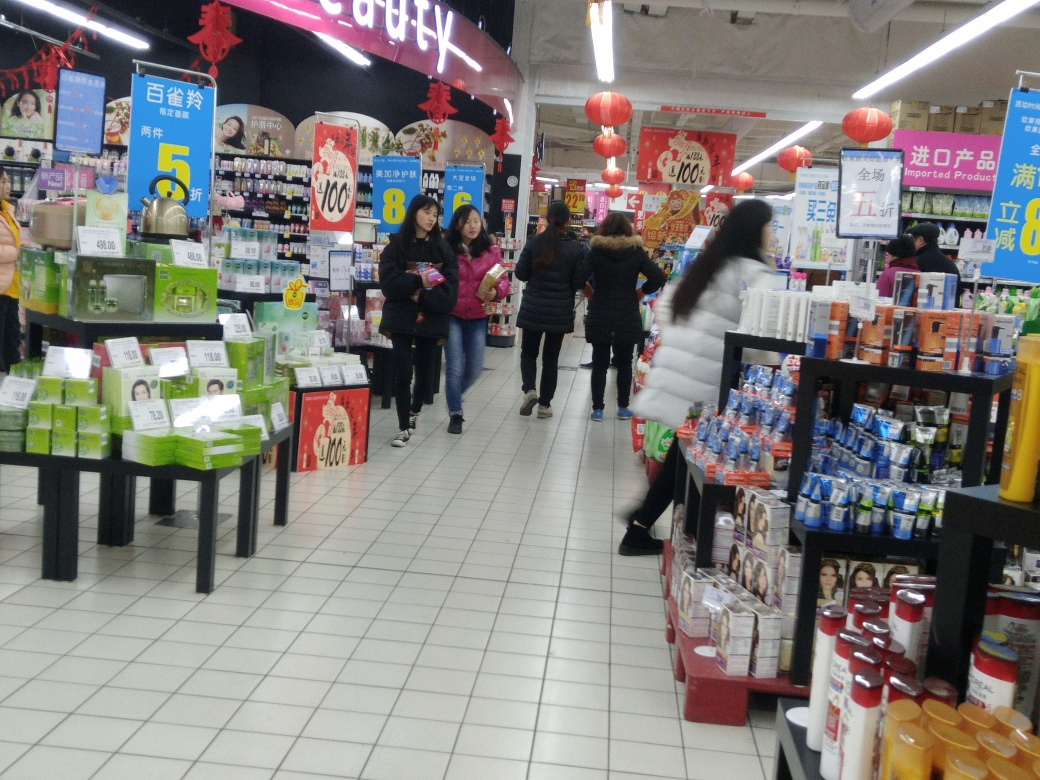Can you describe the setting depicted in this image? Certainly! The image shows an indoor retail setting, likely a supermarket, with customers browsing through different sections. The shelves are stocked with diverse products, and the overhead signs indicate promotions and deals. Red lanterns suggest a festive atmosphere, possibly during a cultural celebration. 